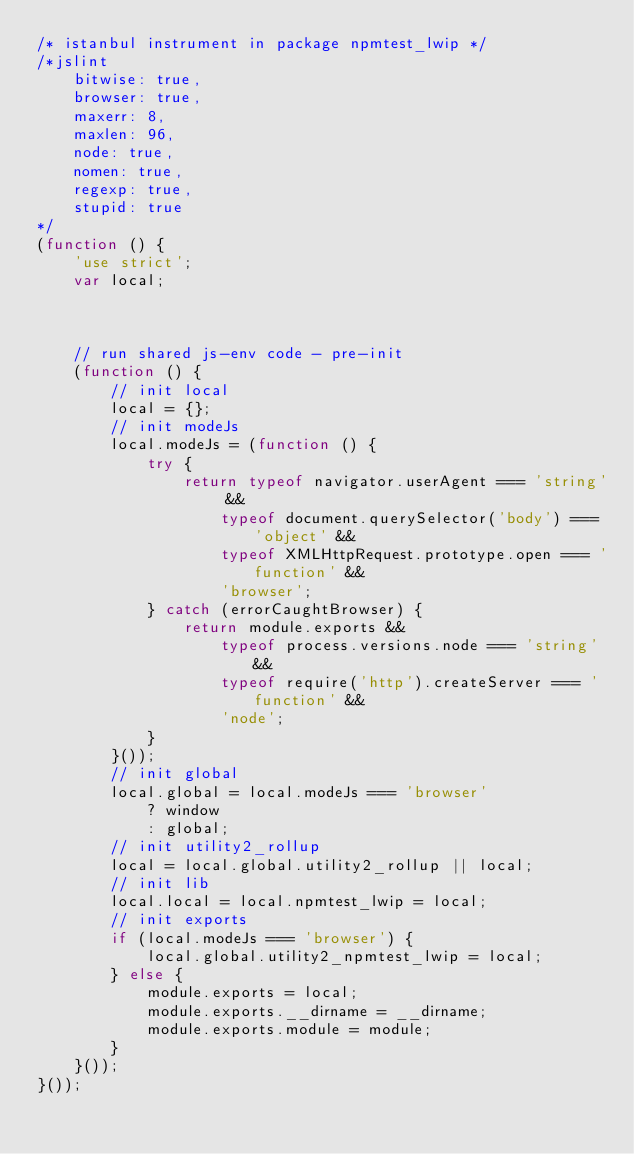Convert code to text. <code><loc_0><loc_0><loc_500><loc_500><_JavaScript_>/* istanbul instrument in package npmtest_lwip */
/*jslint
    bitwise: true,
    browser: true,
    maxerr: 8,
    maxlen: 96,
    node: true,
    nomen: true,
    regexp: true,
    stupid: true
*/
(function () {
    'use strict';
    var local;



    // run shared js-env code - pre-init
    (function () {
        // init local
        local = {};
        // init modeJs
        local.modeJs = (function () {
            try {
                return typeof navigator.userAgent === 'string' &&
                    typeof document.querySelector('body') === 'object' &&
                    typeof XMLHttpRequest.prototype.open === 'function' &&
                    'browser';
            } catch (errorCaughtBrowser) {
                return module.exports &&
                    typeof process.versions.node === 'string' &&
                    typeof require('http').createServer === 'function' &&
                    'node';
            }
        }());
        // init global
        local.global = local.modeJs === 'browser'
            ? window
            : global;
        // init utility2_rollup
        local = local.global.utility2_rollup || local;
        // init lib
        local.local = local.npmtest_lwip = local;
        // init exports
        if (local.modeJs === 'browser') {
            local.global.utility2_npmtest_lwip = local;
        } else {
            module.exports = local;
            module.exports.__dirname = __dirname;
            module.exports.module = module;
        }
    }());
}());
</code> 